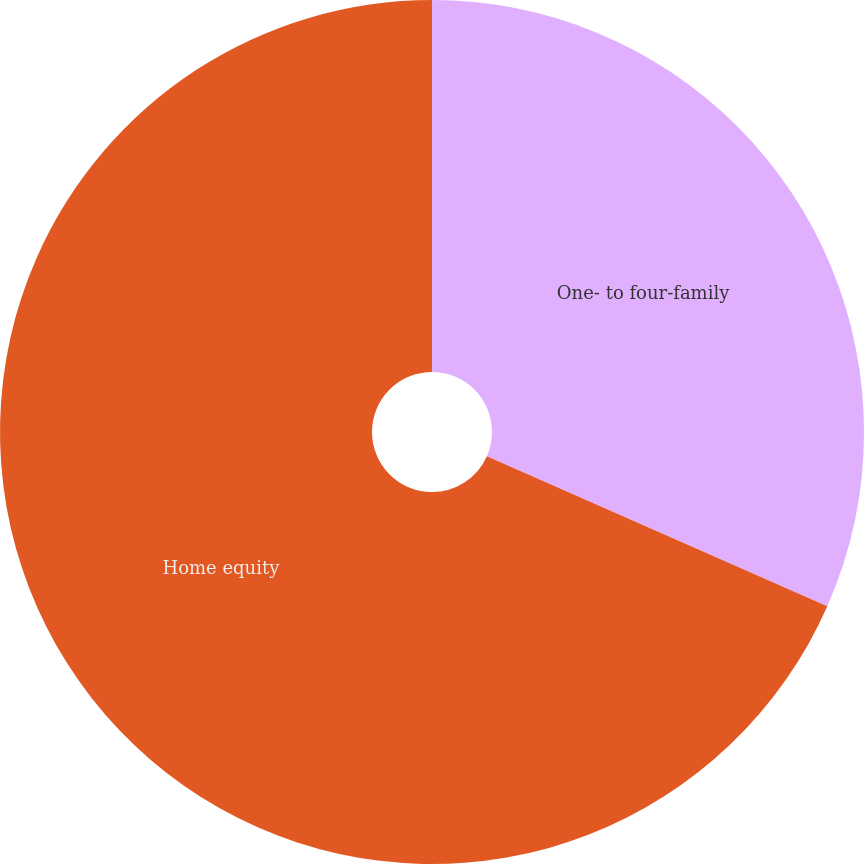Convert chart to OTSL. <chart><loc_0><loc_0><loc_500><loc_500><pie_chart><fcel>One- to four-family<fcel>Home equity<nl><fcel>31.61%<fcel>68.39%<nl></chart> 